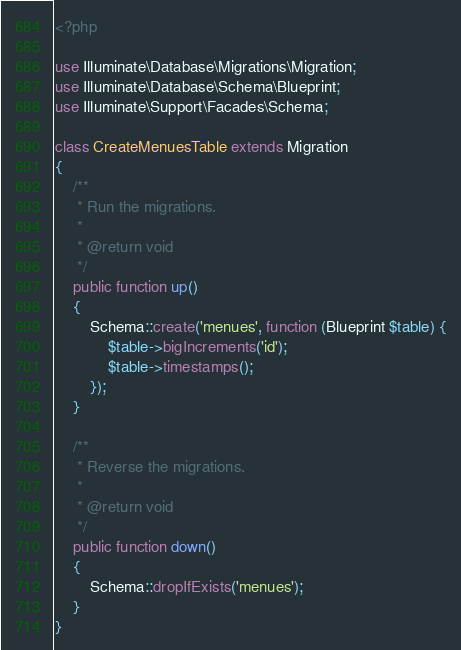<code> <loc_0><loc_0><loc_500><loc_500><_PHP_><?php

use Illuminate\Database\Migrations\Migration;
use Illuminate\Database\Schema\Blueprint;
use Illuminate\Support\Facades\Schema;

class CreateMenuesTable extends Migration
{
    /**
     * Run the migrations.
     *
     * @return void
     */
    public function up()
    {
        Schema::create('menues', function (Blueprint $table) {
            $table->bigIncrements('id');
            $table->timestamps();
        });
    }

    /**
     * Reverse the migrations.
     *
     * @return void
     */
    public function down()
    {
        Schema::dropIfExists('menues');
    }
}
</code> 